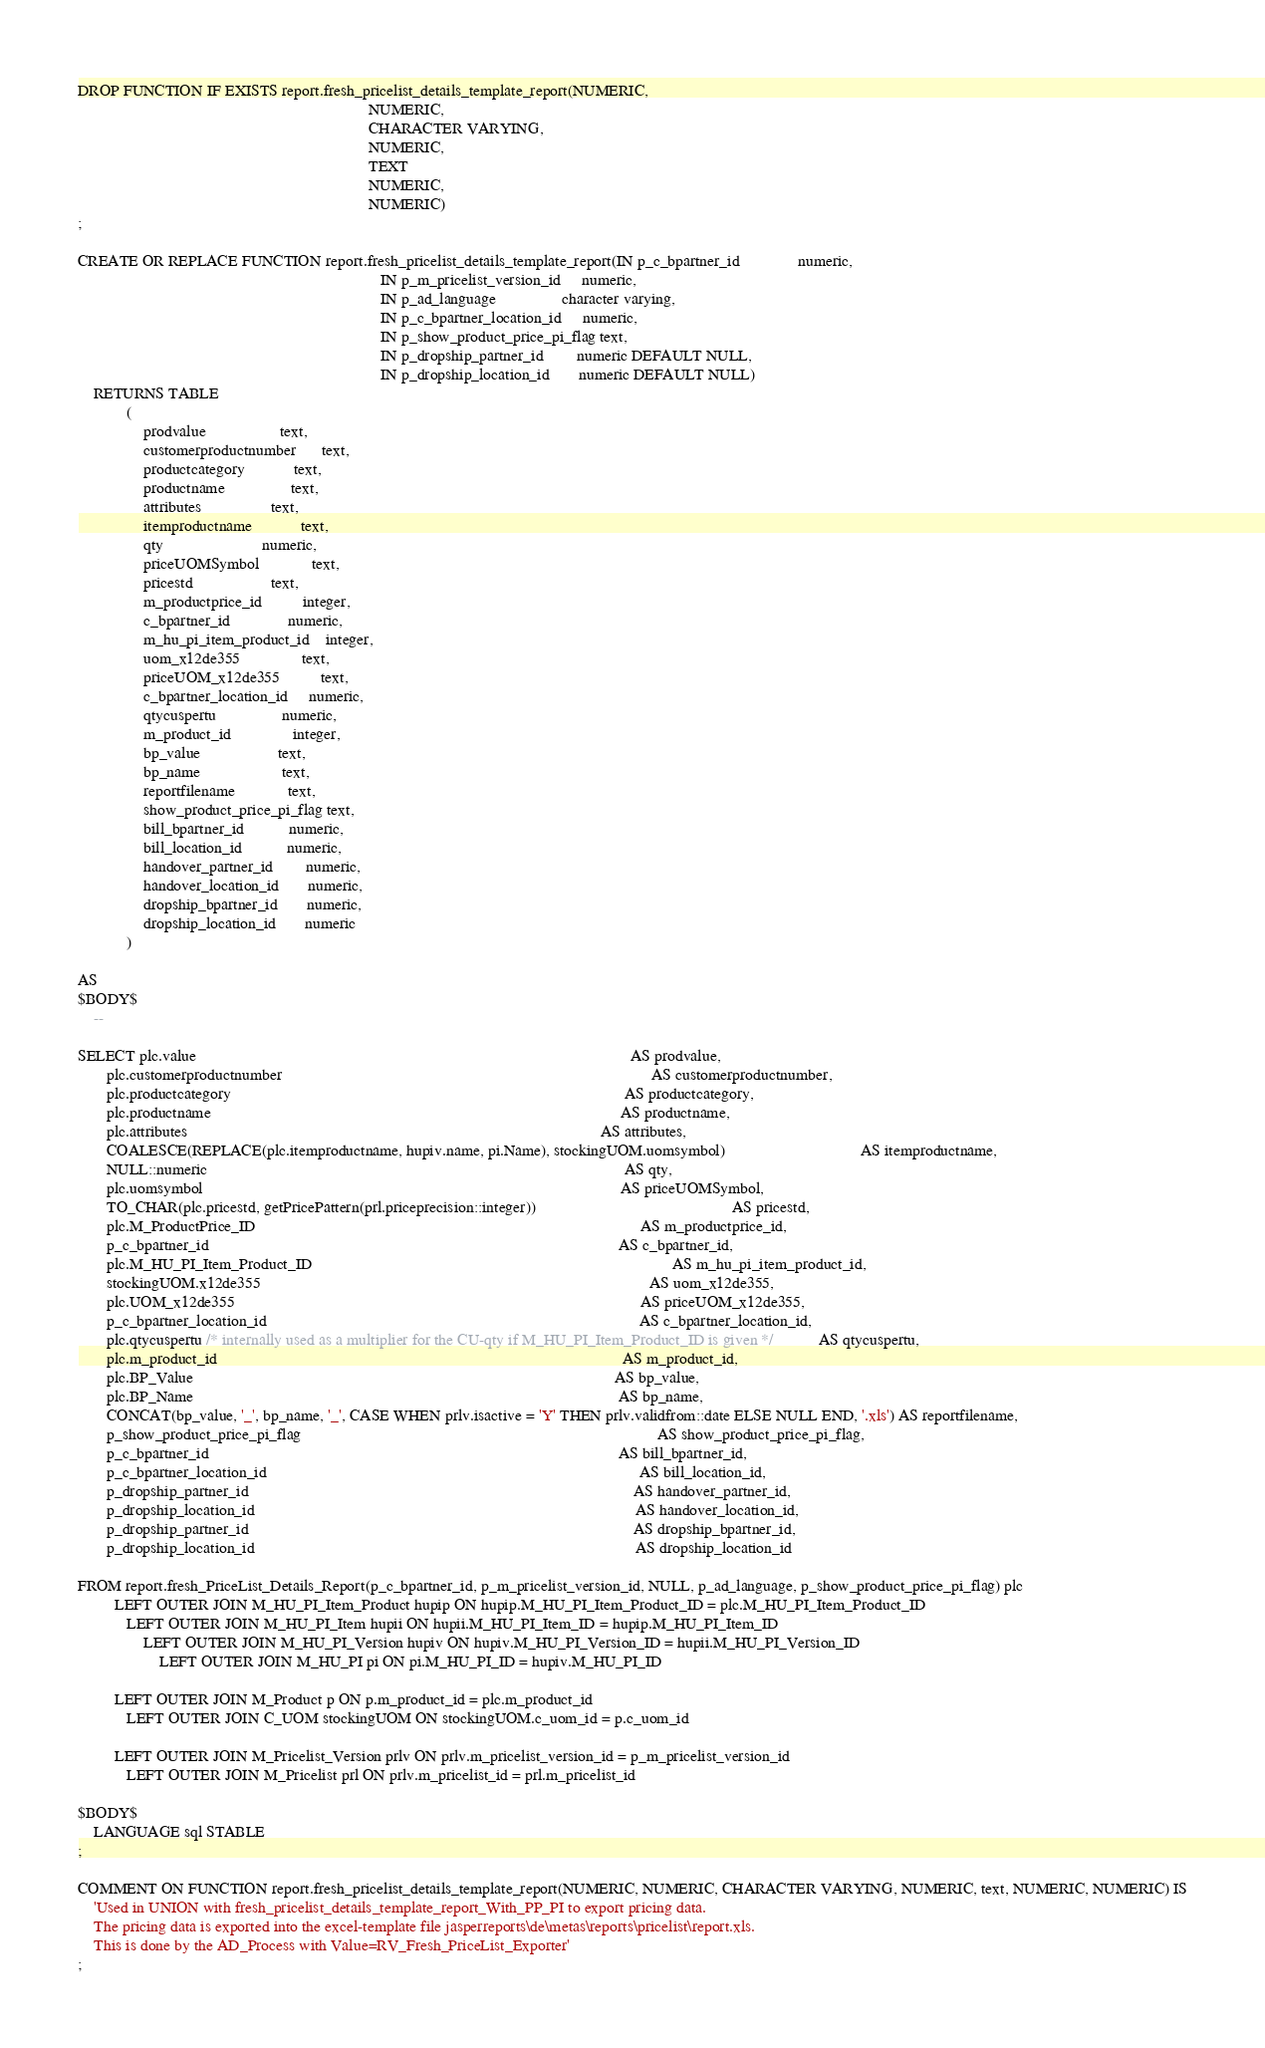<code> <loc_0><loc_0><loc_500><loc_500><_SQL_>DROP FUNCTION IF EXISTS report.fresh_pricelist_details_template_report(NUMERIC,
                                                                       NUMERIC,
                                                                       CHARACTER VARYING,
                                                                       NUMERIC,
                                                                       TEXT
                                                                       NUMERIC,
                                                                       NUMERIC)
;

CREATE OR REPLACE FUNCTION report.fresh_pricelist_details_template_report(IN p_c_bpartner_id              numeric,
                                                                          IN p_m_pricelist_version_id     numeric,
                                                                          IN p_ad_language                character varying,
                                                                          IN p_c_bpartner_location_id     numeric,
                                                                          IN p_show_product_price_pi_flag text,
                                                                          IN p_dropship_partner_id        numeric DEFAULT NULL,
                                                                          IN p_dropship_location_id       numeric DEFAULT NULL)
    RETURNS TABLE
            (
                prodvalue                  text,
                customerproductnumber      text,
                productcategory            text,
                productname                text,
                attributes                 text,
                itemproductname            text,
                qty                        numeric,
                priceUOMSymbol             text,
                pricestd                   text,
                m_productprice_id          integer,
                c_bpartner_id              numeric,
                m_hu_pi_item_product_id    integer,
                uom_x12de355               text,
                priceUOM_x12de355          text,
                c_bpartner_location_id     numeric,
                qtycuspertu                numeric,
                m_product_id               integer,
                bp_value                   text,
                bp_name                    text,
                reportfilename             text,
                show_product_price_pi_flag text,
                bill_bpartner_id           numeric,
                bill_location_id           numeric,
                handover_partner_id        numeric,
                handover_location_id       numeric,
                dropship_bpartner_id       numeric,
                dropship_location_id       numeric
            )

AS
$BODY$
    --

SELECT plc.value                                                                                                          AS prodvalue,
       plc.customerproductnumber                                                                                          AS customerproductnumber,
       plc.productcategory                                                                                                AS productcategory,
       plc.productname                                                                                                    AS productname,
       plc.attributes                                                                                                     AS attributes,
       COALESCE(REPLACE(plc.itemproductname, hupiv.name, pi.Name), stockingUOM.uomsymbol)                                 AS itemproductname,
       NULL::numeric                                                                                                      AS qty,
       plc.uomsymbol                                                                                                      AS priceUOMSymbol,
       TO_CHAR(plc.pricestd, getPricePattern(prl.priceprecision::integer))                                                AS pricestd,
       plc.M_ProductPrice_ID                                                                                              AS m_productprice_id,
       p_c_bpartner_id                                                                                                    AS c_bpartner_id,
       plc.M_HU_PI_Item_Product_ID                                                                                        AS m_hu_pi_item_product_id,
       stockingUOM.x12de355                                                                                               AS uom_x12de355,
       plc.UOM_x12de355                                                                                                   AS priceUOM_x12de355,
       p_c_bpartner_location_id                                                                                           AS c_bpartner_location_id,
       plc.qtycuspertu /* internally used as a multiplier for the CU-qty if M_HU_PI_Item_Product_ID is given */           AS qtycuspertu,
       plc.m_product_id                                                                                                   AS m_product_id,
       plc.BP_Value                                                                                                       AS bp_value,
       plc.BP_Name                                                                                                        AS bp_name,
       CONCAT(bp_value, '_', bp_name, '_', CASE WHEN prlv.isactive = 'Y' THEN prlv.validfrom::date ELSE NULL END, '.xls') AS reportfilename,
       p_show_product_price_pi_flag                                                                                       AS show_product_price_pi_flag,
       p_c_bpartner_id                                                                                                    AS bill_bpartner_id,
       p_c_bpartner_location_id                                                                                           AS bill_location_id,
       p_dropship_partner_id                                                                                              AS handover_partner_id,
       p_dropship_location_id                                                                                             AS handover_location_id,
       p_dropship_partner_id                                                                                              AS dropship_bpartner_id,
       p_dropship_location_id                                                                                             AS dropship_location_id

FROM report.fresh_PriceList_Details_Report(p_c_bpartner_id, p_m_pricelist_version_id, NULL, p_ad_language, p_show_product_price_pi_flag) plc
         LEFT OUTER JOIN M_HU_PI_Item_Product hupip ON hupip.M_HU_PI_Item_Product_ID = plc.M_HU_PI_Item_Product_ID
            LEFT OUTER JOIN M_HU_PI_Item hupii ON hupii.M_HU_PI_Item_ID = hupip.M_HU_PI_Item_ID
                LEFT OUTER JOIN M_HU_PI_Version hupiv ON hupiv.M_HU_PI_Version_ID = hupii.M_HU_PI_Version_ID
                    LEFT OUTER JOIN M_HU_PI pi ON pi.M_HU_PI_ID = hupiv.M_HU_PI_ID

         LEFT OUTER JOIN M_Product p ON p.m_product_id = plc.m_product_id
            LEFT OUTER JOIN C_UOM stockingUOM ON stockingUOM.c_uom_id = p.c_uom_id

         LEFT OUTER JOIN M_Pricelist_Version prlv ON prlv.m_pricelist_version_id = p_m_pricelist_version_id
            LEFT OUTER JOIN M_Pricelist prl ON prlv.m_pricelist_id = prl.m_pricelist_id

$BODY$
    LANGUAGE sql STABLE
;

COMMENT ON FUNCTION report.fresh_pricelist_details_template_report(NUMERIC, NUMERIC, CHARACTER VARYING, NUMERIC, text, NUMERIC, NUMERIC) IS
    'Used in UNION with fresh_pricelist_details_template_report_With_PP_PI to export pricing data.
    The pricing data is exported into the excel-template file jasperreports\de\metas\reports\pricelist\report.xls.
    This is done by the AD_Process with Value=RV_Fresh_PriceList_Exporter'
;
</code> 